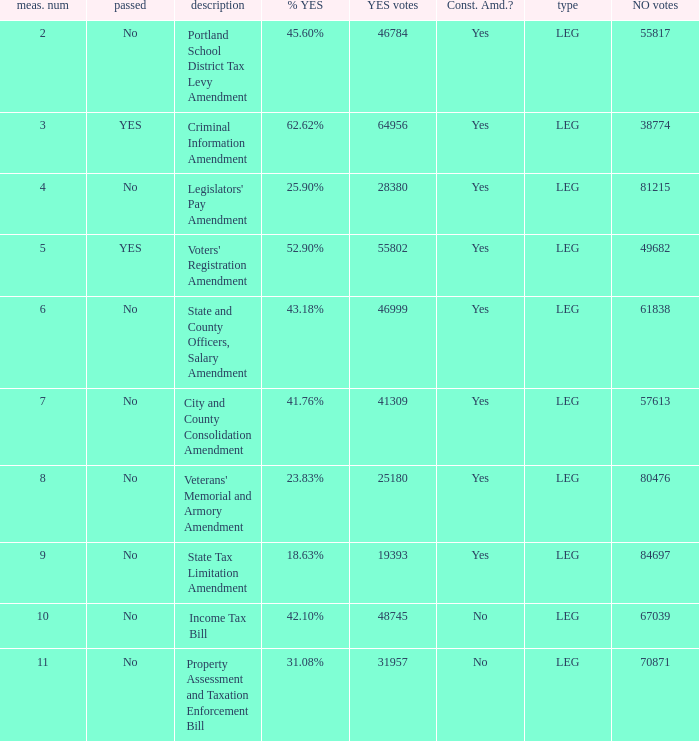Would you be able to parse every entry in this table? {'header': ['meas. num', 'passed', 'description', '% YES', 'YES votes', 'Const. Amd.?', 'type', 'NO votes'], 'rows': [['2', 'No', 'Portland School District Tax Levy Amendment', '45.60%', '46784', 'Yes', 'LEG', '55817'], ['3', 'YES', 'Criminal Information Amendment', '62.62%', '64956', 'Yes', 'LEG', '38774'], ['4', 'No', "Legislators' Pay Amendment", '25.90%', '28380', 'Yes', 'LEG', '81215'], ['5', 'YES', "Voters' Registration Amendment", '52.90%', '55802', 'Yes', 'LEG', '49682'], ['6', 'No', 'State and County Officers, Salary Amendment', '43.18%', '46999', 'Yes', 'LEG', '61838'], ['7', 'No', 'City and County Consolidation Amendment', '41.76%', '41309', 'Yes', 'LEG', '57613'], ['8', 'No', "Veterans' Memorial and Armory Amendment", '23.83%', '25180', 'Yes', 'LEG', '80476'], ['9', 'No', 'State Tax Limitation Amendment', '18.63%', '19393', 'Yes', 'LEG', '84697'], ['10', 'No', 'Income Tax Bill', '42.10%', '48745', 'No', 'LEG', '67039'], ['11', 'No', 'Property Assessment and Taxation Enforcement Bill', '31.08%', '31957', 'No', 'LEG', '70871']]} Who had 41.76% yes votes City and County Consolidation Amendment. 